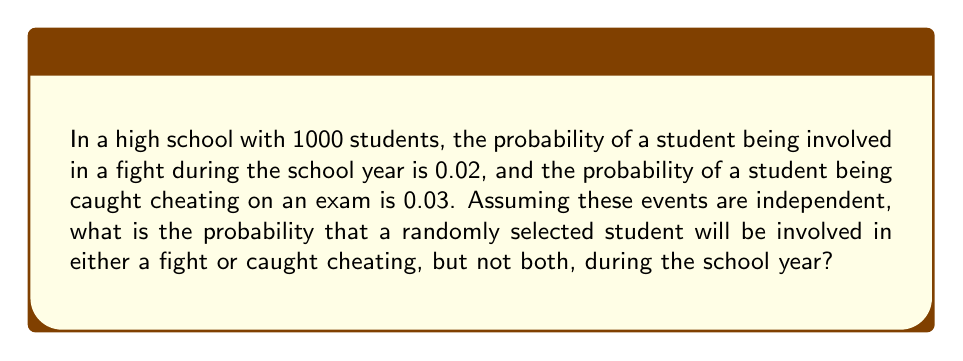Could you help me with this problem? Let's approach this step-by-step:

1) Let $F$ be the event of a student being involved in a fight, and $C$ be the event of a student being caught cheating.

2) Given:
   $P(F) = 0.02$
   $P(C) = 0.03$

3) We need to find $P(F \text{ or } C \text{ but not both})$. This can be expressed as:
   $P((F \cup C) - (F \cap C))$

4) Using the addition rule of probability:
   $P(F \text{ or } C) = P(F) + P(C) - P(F \text{ and } C)$

5) Since the events are independent:
   $P(F \text{ and } C) = P(F) \times P(C) = 0.02 \times 0.03 = 0.0006$

6) Now we can calculate $P(F \text{ or } C)$:
   $P(F \text{ or } C) = 0.02 + 0.03 - 0.0006 = 0.0494$

7) However, we want the probability of either event occurring but not both. So we need to subtract the probability of both events occurring:
   $P(F \text{ or } C \text{ but not both}) = P(F \text{ or } C) - P(F \text{ and } C)$
   $= 0.0494 - 0.0006 = 0.0488$

Therefore, the probability that a randomly selected student will be involved in either a fight or caught cheating, but not both, during the school year is 0.0488 or 4.88%.
Answer: 0.0488 